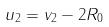Convert formula to latex. <formula><loc_0><loc_0><loc_500><loc_500>u _ { 2 } = v _ { 2 } - 2 R _ { 0 }</formula> 